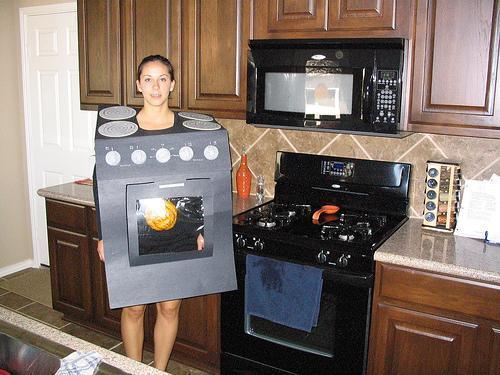How many orange bottles are on the counter?
Give a very brief answer. 1. 